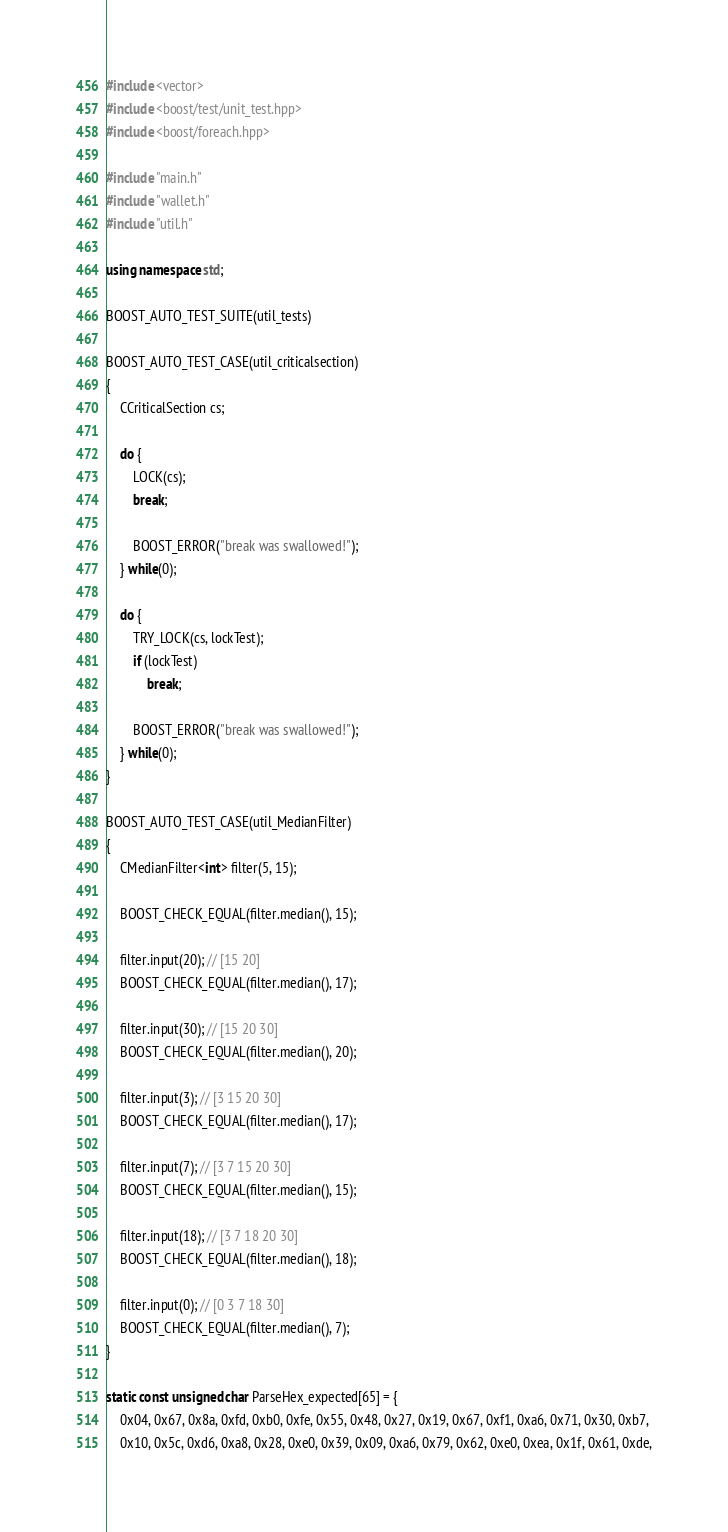Convert code to text. <code><loc_0><loc_0><loc_500><loc_500><_C++_>#include <vector>
#include <boost/test/unit_test.hpp>
#include <boost/foreach.hpp>

#include "main.h"
#include "wallet.h"
#include "util.h"

using namespace std;

BOOST_AUTO_TEST_SUITE(util_tests)

BOOST_AUTO_TEST_CASE(util_criticalsection)
{
    CCriticalSection cs;

    do {
        LOCK(cs);
        break;

        BOOST_ERROR("break was swallowed!");
    } while(0);

    do {
        TRY_LOCK(cs, lockTest);
        if (lockTest)
            break;

        BOOST_ERROR("break was swallowed!");
    } while(0);
}

BOOST_AUTO_TEST_CASE(util_MedianFilter)
{
    CMedianFilter<int> filter(5, 15);

    BOOST_CHECK_EQUAL(filter.median(), 15);

    filter.input(20); // [15 20]
    BOOST_CHECK_EQUAL(filter.median(), 17);

    filter.input(30); // [15 20 30]
    BOOST_CHECK_EQUAL(filter.median(), 20);

    filter.input(3); // [3 15 20 30]
    BOOST_CHECK_EQUAL(filter.median(), 17);

    filter.input(7); // [3 7 15 20 30]
    BOOST_CHECK_EQUAL(filter.median(), 15);

    filter.input(18); // [3 7 18 20 30]
    BOOST_CHECK_EQUAL(filter.median(), 18);

    filter.input(0); // [0 3 7 18 30]
    BOOST_CHECK_EQUAL(filter.median(), 7);
}

static const unsigned char ParseHex_expected[65] = {
    0x04, 0x67, 0x8a, 0xfd, 0xb0, 0xfe, 0x55, 0x48, 0x27, 0x19, 0x67, 0xf1, 0xa6, 0x71, 0x30, 0xb7,
    0x10, 0x5c, 0xd6, 0xa8, 0x28, 0xe0, 0x39, 0x09, 0xa6, 0x79, 0x62, 0xe0, 0xea, 0x1f, 0x61, 0xde,</code> 